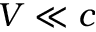<formula> <loc_0><loc_0><loc_500><loc_500>V \ll c</formula> 